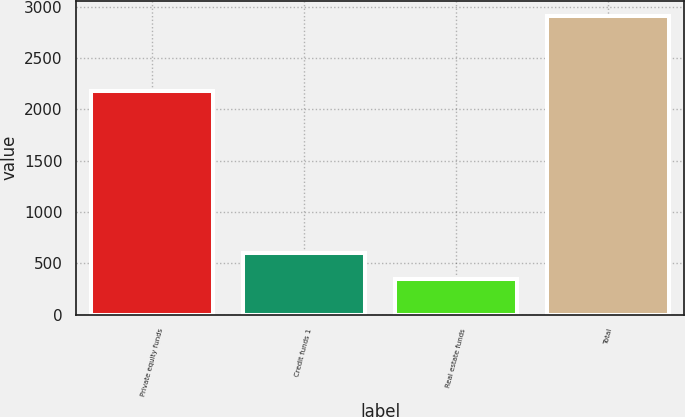<chart> <loc_0><loc_0><loc_500><loc_500><bar_chart><fcel>Private equity funds<fcel>Credit funds 1<fcel>Real estate funds<fcel>Total<nl><fcel>2181<fcel>601.1<fcel>344<fcel>2915<nl></chart> 